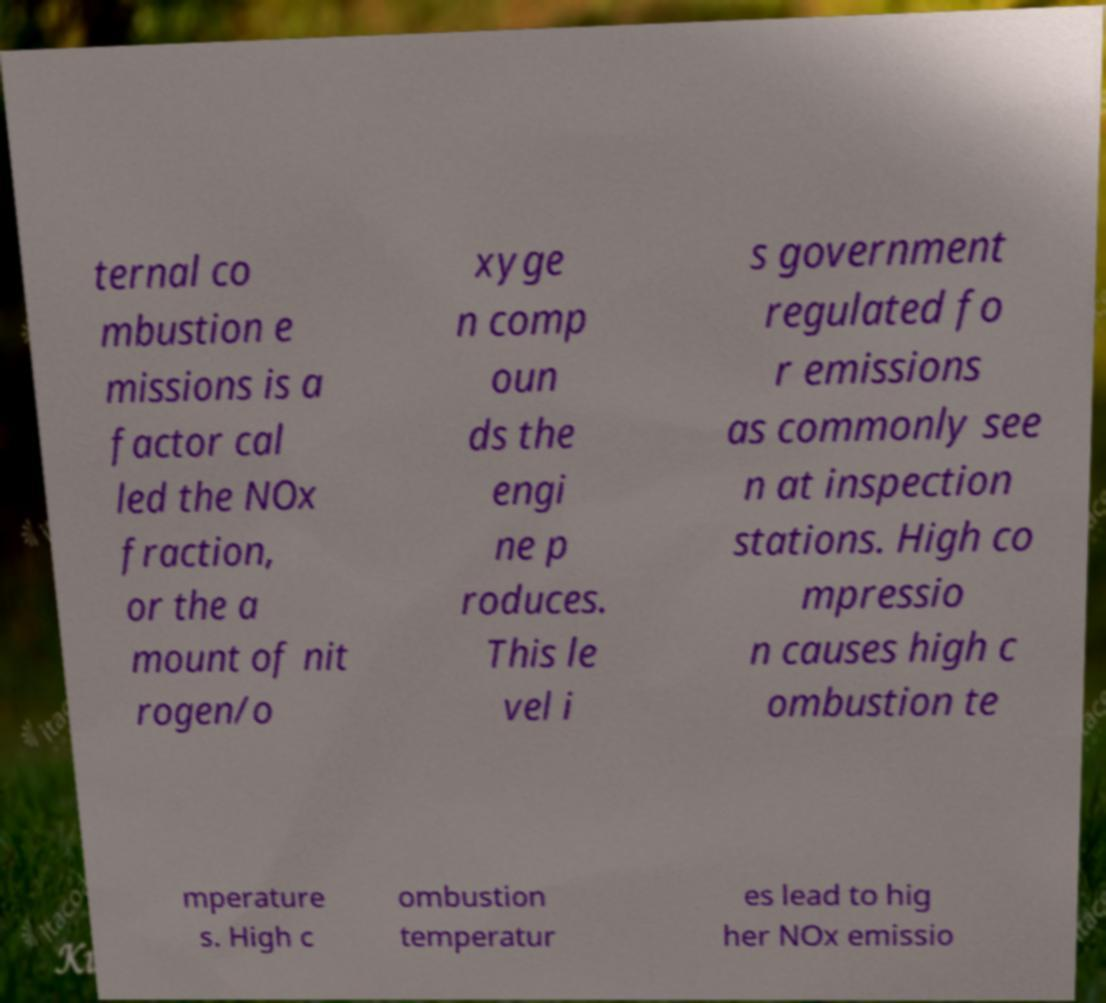There's text embedded in this image that I need extracted. Can you transcribe it verbatim? ternal co mbustion e missions is a factor cal led the NOx fraction, or the a mount of nit rogen/o xyge n comp oun ds the engi ne p roduces. This le vel i s government regulated fo r emissions as commonly see n at inspection stations. High co mpressio n causes high c ombustion te mperature s. High c ombustion temperatur es lead to hig her NOx emissio 